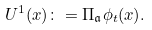Convert formula to latex. <formula><loc_0><loc_0><loc_500><loc_500>U ^ { 1 } ( x ) \colon = \Pi _ { \mathfrak { a } } \phi _ { t } ( x ) .</formula> 